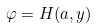Convert formula to latex. <formula><loc_0><loc_0><loc_500><loc_500>\varphi = H ( a , y )</formula> 